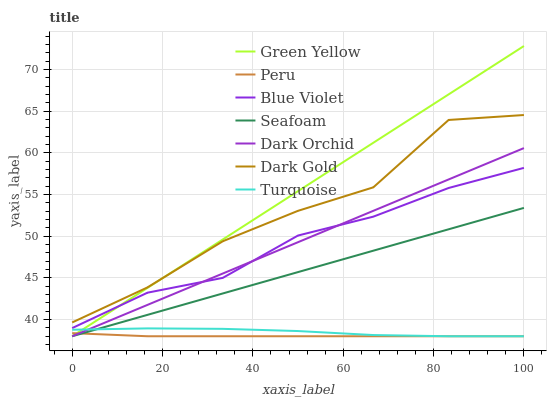Does Peru have the minimum area under the curve?
Answer yes or no. Yes. Does Green Yellow have the maximum area under the curve?
Answer yes or no. Yes. Does Dark Gold have the minimum area under the curve?
Answer yes or no. No. Does Dark Gold have the maximum area under the curve?
Answer yes or no. No. Is Seafoam the smoothest?
Answer yes or no. Yes. Is Dark Gold the roughest?
Answer yes or no. Yes. Is Dark Gold the smoothest?
Answer yes or no. No. Is Seafoam the roughest?
Answer yes or no. No. Does Turquoise have the lowest value?
Answer yes or no. Yes. Does Dark Gold have the lowest value?
Answer yes or no. No. Does Green Yellow have the highest value?
Answer yes or no. Yes. Does Dark Gold have the highest value?
Answer yes or no. No. Is Turquoise less than Dark Gold?
Answer yes or no. Yes. Is Blue Violet greater than Turquoise?
Answer yes or no. Yes. Does Blue Violet intersect Green Yellow?
Answer yes or no. Yes. Is Blue Violet less than Green Yellow?
Answer yes or no. No. Is Blue Violet greater than Green Yellow?
Answer yes or no. No. Does Turquoise intersect Dark Gold?
Answer yes or no. No. 